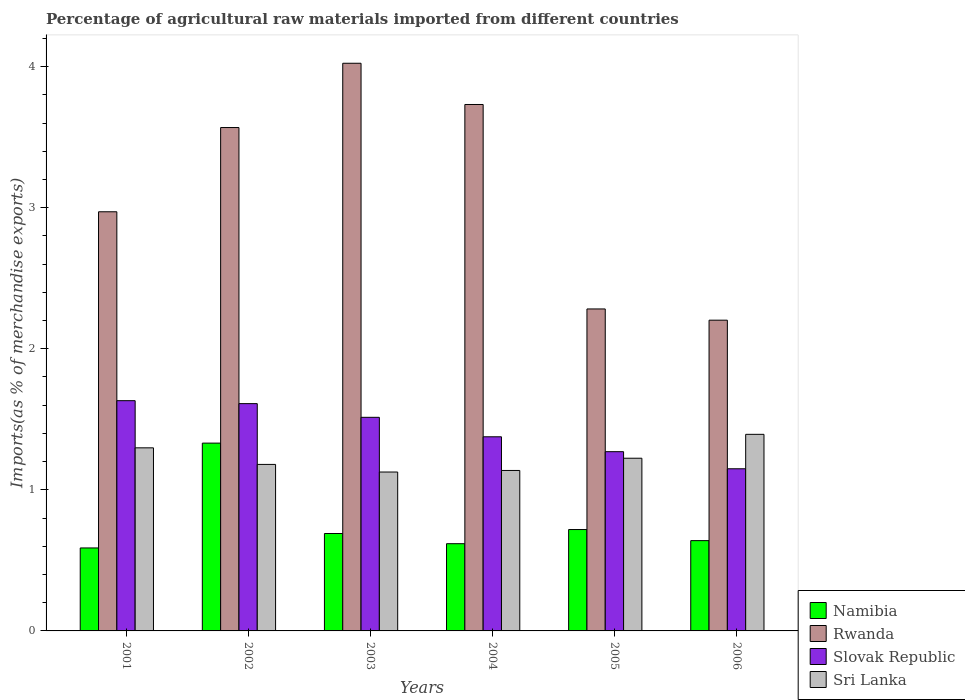How many different coloured bars are there?
Give a very brief answer. 4. How many groups of bars are there?
Keep it short and to the point. 6. Are the number of bars on each tick of the X-axis equal?
Your response must be concise. Yes. How many bars are there on the 2nd tick from the left?
Make the answer very short. 4. How many bars are there on the 2nd tick from the right?
Keep it short and to the point. 4. What is the percentage of imports to different countries in Slovak Republic in 2001?
Ensure brevity in your answer.  1.63. Across all years, what is the maximum percentage of imports to different countries in Rwanda?
Your answer should be very brief. 4.02. Across all years, what is the minimum percentage of imports to different countries in Namibia?
Provide a succinct answer. 0.59. What is the total percentage of imports to different countries in Sri Lanka in the graph?
Offer a terse response. 7.36. What is the difference between the percentage of imports to different countries in Rwanda in 2005 and that in 2006?
Your answer should be compact. 0.08. What is the difference between the percentage of imports to different countries in Slovak Republic in 2003 and the percentage of imports to different countries in Rwanda in 2006?
Your response must be concise. -0.69. What is the average percentage of imports to different countries in Sri Lanka per year?
Offer a terse response. 1.23. In the year 2002, what is the difference between the percentage of imports to different countries in Slovak Republic and percentage of imports to different countries in Sri Lanka?
Provide a succinct answer. 0.43. What is the ratio of the percentage of imports to different countries in Sri Lanka in 2003 to that in 2004?
Give a very brief answer. 0.99. What is the difference between the highest and the second highest percentage of imports to different countries in Slovak Republic?
Offer a terse response. 0.02. What is the difference between the highest and the lowest percentage of imports to different countries in Namibia?
Keep it short and to the point. 0.74. In how many years, is the percentage of imports to different countries in Sri Lanka greater than the average percentage of imports to different countries in Sri Lanka taken over all years?
Your answer should be very brief. 2. What does the 1st bar from the left in 2003 represents?
Keep it short and to the point. Namibia. What does the 4th bar from the right in 2004 represents?
Offer a very short reply. Namibia. Are all the bars in the graph horizontal?
Your answer should be very brief. No. What is the difference between two consecutive major ticks on the Y-axis?
Your answer should be very brief. 1. Does the graph contain any zero values?
Make the answer very short. No. How are the legend labels stacked?
Provide a succinct answer. Vertical. What is the title of the graph?
Ensure brevity in your answer.  Percentage of agricultural raw materials imported from different countries. What is the label or title of the Y-axis?
Your answer should be very brief. Imports(as % of merchandise exports). What is the Imports(as % of merchandise exports) in Namibia in 2001?
Make the answer very short. 0.59. What is the Imports(as % of merchandise exports) in Rwanda in 2001?
Ensure brevity in your answer.  2.97. What is the Imports(as % of merchandise exports) of Slovak Republic in 2001?
Make the answer very short. 1.63. What is the Imports(as % of merchandise exports) of Sri Lanka in 2001?
Keep it short and to the point. 1.3. What is the Imports(as % of merchandise exports) of Namibia in 2002?
Keep it short and to the point. 1.33. What is the Imports(as % of merchandise exports) of Rwanda in 2002?
Provide a short and direct response. 3.57. What is the Imports(as % of merchandise exports) of Slovak Republic in 2002?
Provide a short and direct response. 1.61. What is the Imports(as % of merchandise exports) of Sri Lanka in 2002?
Provide a short and direct response. 1.18. What is the Imports(as % of merchandise exports) in Namibia in 2003?
Your answer should be compact. 0.69. What is the Imports(as % of merchandise exports) in Rwanda in 2003?
Ensure brevity in your answer.  4.02. What is the Imports(as % of merchandise exports) of Slovak Republic in 2003?
Your response must be concise. 1.51. What is the Imports(as % of merchandise exports) in Sri Lanka in 2003?
Your answer should be very brief. 1.13. What is the Imports(as % of merchandise exports) of Namibia in 2004?
Make the answer very short. 0.62. What is the Imports(as % of merchandise exports) in Rwanda in 2004?
Give a very brief answer. 3.73. What is the Imports(as % of merchandise exports) of Slovak Republic in 2004?
Offer a terse response. 1.38. What is the Imports(as % of merchandise exports) of Sri Lanka in 2004?
Provide a short and direct response. 1.14. What is the Imports(as % of merchandise exports) in Namibia in 2005?
Provide a succinct answer. 0.72. What is the Imports(as % of merchandise exports) of Rwanda in 2005?
Your answer should be compact. 2.28. What is the Imports(as % of merchandise exports) of Slovak Republic in 2005?
Offer a terse response. 1.27. What is the Imports(as % of merchandise exports) of Sri Lanka in 2005?
Offer a very short reply. 1.22. What is the Imports(as % of merchandise exports) in Namibia in 2006?
Your answer should be compact. 0.64. What is the Imports(as % of merchandise exports) in Rwanda in 2006?
Your response must be concise. 2.2. What is the Imports(as % of merchandise exports) in Slovak Republic in 2006?
Your answer should be compact. 1.15. What is the Imports(as % of merchandise exports) in Sri Lanka in 2006?
Provide a succinct answer. 1.39. Across all years, what is the maximum Imports(as % of merchandise exports) in Namibia?
Your answer should be very brief. 1.33. Across all years, what is the maximum Imports(as % of merchandise exports) of Rwanda?
Provide a succinct answer. 4.02. Across all years, what is the maximum Imports(as % of merchandise exports) of Slovak Republic?
Provide a succinct answer. 1.63. Across all years, what is the maximum Imports(as % of merchandise exports) of Sri Lanka?
Offer a terse response. 1.39. Across all years, what is the minimum Imports(as % of merchandise exports) in Namibia?
Keep it short and to the point. 0.59. Across all years, what is the minimum Imports(as % of merchandise exports) in Rwanda?
Your answer should be very brief. 2.2. Across all years, what is the minimum Imports(as % of merchandise exports) in Slovak Republic?
Your answer should be compact. 1.15. Across all years, what is the minimum Imports(as % of merchandise exports) in Sri Lanka?
Your answer should be very brief. 1.13. What is the total Imports(as % of merchandise exports) in Namibia in the graph?
Your answer should be compact. 4.59. What is the total Imports(as % of merchandise exports) of Rwanda in the graph?
Keep it short and to the point. 18.78. What is the total Imports(as % of merchandise exports) in Slovak Republic in the graph?
Your answer should be very brief. 8.55. What is the total Imports(as % of merchandise exports) of Sri Lanka in the graph?
Keep it short and to the point. 7.36. What is the difference between the Imports(as % of merchandise exports) of Namibia in 2001 and that in 2002?
Offer a very short reply. -0.74. What is the difference between the Imports(as % of merchandise exports) in Rwanda in 2001 and that in 2002?
Offer a terse response. -0.6. What is the difference between the Imports(as % of merchandise exports) of Slovak Republic in 2001 and that in 2002?
Keep it short and to the point. 0.02. What is the difference between the Imports(as % of merchandise exports) in Sri Lanka in 2001 and that in 2002?
Your response must be concise. 0.12. What is the difference between the Imports(as % of merchandise exports) in Namibia in 2001 and that in 2003?
Make the answer very short. -0.1. What is the difference between the Imports(as % of merchandise exports) in Rwanda in 2001 and that in 2003?
Your answer should be very brief. -1.05. What is the difference between the Imports(as % of merchandise exports) in Slovak Republic in 2001 and that in 2003?
Keep it short and to the point. 0.12. What is the difference between the Imports(as % of merchandise exports) in Sri Lanka in 2001 and that in 2003?
Ensure brevity in your answer.  0.17. What is the difference between the Imports(as % of merchandise exports) of Namibia in 2001 and that in 2004?
Offer a very short reply. -0.03. What is the difference between the Imports(as % of merchandise exports) of Rwanda in 2001 and that in 2004?
Ensure brevity in your answer.  -0.76. What is the difference between the Imports(as % of merchandise exports) in Slovak Republic in 2001 and that in 2004?
Provide a succinct answer. 0.26. What is the difference between the Imports(as % of merchandise exports) of Sri Lanka in 2001 and that in 2004?
Offer a terse response. 0.16. What is the difference between the Imports(as % of merchandise exports) in Namibia in 2001 and that in 2005?
Ensure brevity in your answer.  -0.13. What is the difference between the Imports(as % of merchandise exports) of Rwanda in 2001 and that in 2005?
Offer a terse response. 0.69. What is the difference between the Imports(as % of merchandise exports) in Slovak Republic in 2001 and that in 2005?
Provide a succinct answer. 0.36. What is the difference between the Imports(as % of merchandise exports) in Sri Lanka in 2001 and that in 2005?
Ensure brevity in your answer.  0.07. What is the difference between the Imports(as % of merchandise exports) of Namibia in 2001 and that in 2006?
Ensure brevity in your answer.  -0.05. What is the difference between the Imports(as % of merchandise exports) of Rwanda in 2001 and that in 2006?
Offer a terse response. 0.77. What is the difference between the Imports(as % of merchandise exports) of Slovak Republic in 2001 and that in 2006?
Offer a terse response. 0.48. What is the difference between the Imports(as % of merchandise exports) in Sri Lanka in 2001 and that in 2006?
Give a very brief answer. -0.1. What is the difference between the Imports(as % of merchandise exports) in Namibia in 2002 and that in 2003?
Give a very brief answer. 0.64. What is the difference between the Imports(as % of merchandise exports) of Rwanda in 2002 and that in 2003?
Offer a terse response. -0.46. What is the difference between the Imports(as % of merchandise exports) of Slovak Republic in 2002 and that in 2003?
Ensure brevity in your answer.  0.1. What is the difference between the Imports(as % of merchandise exports) of Sri Lanka in 2002 and that in 2003?
Provide a succinct answer. 0.05. What is the difference between the Imports(as % of merchandise exports) of Namibia in 2002 and that in 2004?
Your answer should be compact. 0.71. What is the difference between the Imports(as % of merchandise exports) in Rwanda in 2002 and that in 2004?
Your answer should be compact. -0.16. What is the difference between the Imports(as % of merchandise exports) in Slovak Republic in 2002 and that in 2004?
Provide a short and direct response. 0.23. What is the difference between the Imports(as % of merchandise exports) of Sri Lanka in 2002 and that in 2004?
Provide a succinct answer. 0.04. What is the difference between the Imports(as % of merchandise exports) in Namibia in 2002 and that in 2005?
Offer a terse response. 0.61. What is the difference between the Imports(as % of merchandise exports) in Rwanda in 2002 and that in 2005?
Your response must be concise. 1.29. What is the difference between the Imports(as % of merchandise exports) in Slovak Republic in 2002 and that in 2005?
Keep it short and to the point. 0.34. What is the difference between the Imports(as % of merchandise exports) in Sri Lanka in 2002 and that in 2005?
Your response must be concise. -0.04. What is the difference between the Imports(as % of merchandise exports) of Namibia in 2002 and that in 2006?
Give a very brief answer. 0.69. What is the difference between the Imports(as % of merchandise exports) in Rwanda in 2002 and that in 2006?
Give a very brief answer. 1.37. What is the difference between the Imports(as % of merchandise exports) in Slovak Republic in 2002 and that in 2006?
Ensure brevity in your answer.  0.46. What is the difference between the Imports(as % of merchandise exports) of Sri Lanka in 2002 and that in 2006?
Keep it short and to the point. -0.21. What is the difference between the Imports(as % of merchandise exports) of Namibia in 2003 and that in 2004?
Make the answer very short. 0.07. What is the difference between the Imports(as % of merchandise exports) in Rwanda in 2003 and that in 2004?
Give a very brief answer. 0.29. What is the difference between the Imports(as % of merchandise exports) of Slovak Republic in 2003 and that in 2004?
Ensure brevity in your answer.  0.14. What is the difference between the Imports(as % of merchandise exports) in Sri Lanka in 2003 and that in 2004?
Your answer should be compact. -0.01. What is the difference between the Imports(as % of merchandise exports) in Namibia in 2003 and that in 2005?
Provide a succinct answer. -0.03. What is the difference between the Imports(as % of merchandise exports) of Rwanda in 2003 and that in 2005?
Provide a succinct answer. 1.74. What is the difference between the Imports(as % of merchandise exports) of Slovak Republic in 2003 and that in 2005?
Provide a succinct answer. 0.24. What is the difference between the Imports(as % of merchandise exports) of Sri Lanka in 2003 and that in 2005?
Provide a short and direct response. -0.1. What is the difference between the Imports(as % of merchandise exports) of Namibia in 2003 and that in 2006?
Make the answer very short. 0.05. What is the difference between the Imports(as % of merchandise exports) in Rwanda in 2003 and that in 2006?
Ensure brevity in your answer.  1.82. What is the difference between the Imports(as % of merchandise exports) in Slovak Republic in 2003 and that in 2006?
Your answer should be compact. 0.36. What is the difference between the Imports(as % of merchandise exports) in Sri Lanka in 2003 and that in 2006?
Ensure brevity in your answer.  -0.27. What is the difference between the Imports(as % of merchandise exports) in Namibia in 2004 and that in 2005?
Your answer should be very brief. -0.1. What is the difference between the Imports(as % of merchandise exports) in Rwanda in 2004 and that in 2005?
Offer a very short reply. 1.45. What is the difference between the Imports(as % of merchandise exports) of Slovak Republic in 2004 and that in 2005?
Keep it short and to the point. 0.11. What is the difference between the Imports(as % of merchandise exports) of Sri Lanka in 2004 and that in 2005?
Provide a succinct answer. -0.09. What is the difference between the Imports(as % of merchandise exports) in Namibia in 2004 and that in 2006?
Your response must be concise. -0.02. What is the difference between the Imports(as % of merchandise exports) of Rwanda in 2004 and that in 2006?
Provide a short and direct response. 1.53. What is the difference between the Imports(as % of merchandise exports) of Slovak Republic in 2004 and that in 2006?
Offer a very short reply. 0.23. What is the difference between the Imports(as % of merchandise exports) of Sri Lanka in 2004 and that in 2006?
Offer a terse response. -0.26. What is the difference between the Imports(as % of merchandise exports) in Namibia in 2005 and that in 2006?
Offer a very short reply. 0.08. What is the difference between the Imports(as % of merchandise exports) of Rwanda in 2005 and that in 2006?
Offer a very short reply. 0.08. What is the difference between the Imports(as % of merchandise exports) of Slovak Republic in 2005 and that in 2006?
Keep it short and to the point. 0.12. What is the difference between the Imports(as % of merchandise exports) in Sri Lanka in 2005 and that in 2006?
Offer a terse response. -0.17. What is the difference between the Imports(as % of merchandise exports) in Namibia in 2001 and the Imports(as % of merchandise exports) in Rwanda in 2002?
Ensure brevity in your answer.  -2.98. What is the difference between the Imports(as % of merchandise exports) in Namibia in 2001 and the Imports(as % of merchandise exports) in Slovak Republic in 2002?
Your answer should be compact. -1.02. What is the difference between the Imports(as % of merchandise exports) of Namibia in 2001 and the Imports(as % of merchandise exports) of Sri Lanka in 2002?
Make the answer very short. -0.59. What is the difference between the Imports(as % of merchandise exports) in Rwanda in 2001 and the Imports(as % of merchandise exports) in Slovak Republic in 2002?
Your answer should be compact. 1.36. What is the difference between the Imports(as % of merchandise exports) of Rwanda in 2001 and the Imports(as % of merchandise exports) of Sri Lanka in 2002?
Your answer should be compact. 1.79. What is the difference between the Imports(as % of merchandise exports) of Slovak Republic in 2001 and the Imports(as % of merchandise exports) of Sri Lanka in 2002?
Provide a succinct answer. 0.45. What is the difference between the Imports(as % of merchandise exports) in Namibia in 2001 and the Imports(as % of merchandise exports) in Rwanda in 2003?
Your answer should be compact. -3.44. What is the difference between the Imports(as % of merchandise exports) in Namibia in 2001 and the Imports(as % of merchandise exports) in Slovak Republic in 2003?
Your answer should be very brief. -0.93. What is the difference between the Imports(as % of merchandise exports) in Namibia in 2001 and the Imports(as % of merchandise exports) in Sri Lanka in 2003?
Offer a very short reply. -0.54. What is the difference between the Imports(as % of merchandise exports) of Rwanda in 2001 and the Imports(as % of merchandise exports) of Slovak Republic in 2003?
Offer a very short reply. 1.46. What is the difference between the Imports(as % of merchandise exports) in Rwanda in 2001 and the Imports(as % of merchandise exports) in Sri Lanka in 2003?
Offer a terse response. 1.84. What is the difference between the Imports(as % of merchandise exports) in Slovak Republic in 2001 and the Imports(as % of merchandise exports) in Sri Lanka in 2003?
Provide a short and direct response. 0.51. What is the difference between the Imports(as % of merchandise exports) in Namibia in 2001 and the Imports(as % of merchandise exports) in Rwanda in 2004?
Your answer should be very brief. -3.14. What is the difference between the Imports(as % of merchandise exports) of Namibia in 2001 and the Imports(as % of merchandise exports) of Slovak Republic in 2004?
Ensure brevity in your answer.  -0.79. What is the difference between the Imports(as % of merchandise exports) in Namibia in 2001 and the Imports(as % of merchandise exports) in Sri Lanka in 2004?
Your response must be concise. -0.55. What is the difference between the Imports(as % of merchandise exports) of Rwanda in 2001 and the Imports(as % of merchandise exports) of Slovak Republic in 2004?
Provide a short and direct response. 1.59. What is the difference between the Imports(as % of merchandise exports) of Rwanda in 2001 and the Imports(as % of merchandise exports) of Sri Lanka in 2004?
Provide a short and direct response. 1.83. What is the difference between the Imports(as % of merchandise exports) of Slovak Republic in 2001 and the Imports(as % of merchandise exports) of Sri Lanka in 2004?
Ensure brevity in your answer.  0.49. What is the difference between the Imports(as % of merchandise exports) of Namibia in 2001 and the Imports(as % of merchandise exports) of Rwanda in 2005?
Provide a succinct answer. -1.69. What is the difference between the Imports(as % of merchandise exports) of Namibia in 2001 and the Imports(as % of merchandise exports) of Slovak Republic in 2005?
Your answer should be very brief. -0.68. What is the difference between the Imports(as % of merchandise exports) in Namibia in 2001 and the Imports(as % of merchandise exports) in Sri Lanka in 2005?
Offer a very short reply. -0.64. What is the difference between the Imports(as % of merchandise exports) in Rwanda in 2001 and the Imports(as % of merchandise exports) in Slovak Republic in 2005?
Your answer should be compact. 1.7. What is the difference between the Imports(as % of merchandise exports) in Rwanda in 2001 and the Imports(as % of merchandise exports) in Sri Lanka in 2005?
Make the answer very short. 1.75. What is the difference between the Imports(as % of merchandise exports) in Slovak Republic in 2001 and the Imports(as % of merchandise exports) in Sri Lanka in 2005?
Make the answer very short. 0.41. What is the difference between the Imports(as % of merchandise exports) in Namibia in 2001 and the Imports(as % of merchandise exports) in Rwanda in 2006?
Provide a succinct answer. -1.61. What is the difference between the Imports(as % of merchandise exports) in Namibia in 2001 and the Imports(as % of merchandise exports) in Slovak Republic in 2006?
Provide a succinct answer. -0.56. What is the difference between the Imports(as % of merchandise exports) of Namibia in 2001 and the Imports(as % of merchandise exports) of Sri Lanka in 2006?
Your answer should be very brief. -0.81. What is the difference between the Imports(as % of merchandise exports) in Rwanda in 2001 and the Imports(as % of merchandise exports) in Slovak Republic in 2006?
Your answer should be very brief. 1.82. What is the difference between the Imports(as % of merchandise exports) in Rwanda in 2001 and the Imports(as % of merchandise exports) in Sri Lanka in 2006?
Give a very brief answer. 1.58. What is the difference between the Imports(as % of merchandise exports) of Slovak Republic in 2001 and the Imports(as % of merchandise exports) of Sri Lanka in 2006?
Your response must be concise. 0.24. What is the difference between the Imports(as % of merchandise exports) of Namibia in 2002 and the Imports(as % of merchandise exports) of Rwanda in 2003?
Your response must be concise. -2.69. What is the difference between the Imports(as % of merchandise exports) in Namibia in 2002 and the Imports(as % of merchandise exports) in Slovak Republic in 2003?
Keep it short and to the point. -0.18. What is the difference between the Imports(as % of merchandise exports) of Namibia in 2002 and the Imports(as % of merchandise exports) of Sri Lanka in 2003?
Your response must be concise. 0.2. What is the difference between the Imports(as % of merchandise exports) in Rwanda in 2002 and the Imports(as % of merchandise exports) in Slovak Republic in 2003?
Provide a short and direct response. 2.05. What is the difference between the Imports(as % of merchandise exports) of Rwanda in 2002 and the Imports(as % of merchandise exports) of Sri Lanka in 2003?
Ensure brevity in your answer.  2.44. What is the difference between the Imports(as % of merchandise exports) of Slovak Republic in 2002 and the Imports(as % of merchandise exports) of Sri Lanka in 2003?
Offer a terse response. 0.48. What is the difference between the Imports(as % of merchandise exports) of Namibia in 2002 and the Imports(as % of merchandise exports) of Rwanda in 2004?
Ensure brevity in your answer.  -2.4. What is the difference between the Imports(as % of merchandise exports) of Namibia in 2002 and the Imports(as % of merchandise exports) of Slovak Republic in 2004?
Provide a short and direct response. -0.04. What is the difference between the Imports(as % of merchandise exports) in Namibia in 2002 and the Imports(as % of merchandise exports) in Sri Lanka in 2004?
Provide a succinct answer. 0.19. What is the difference between the Imports(as % of merchandise exports) of Rwanda in 2002 and the Imports(as % of merchandise exports) of Slovak Republic in 2004?
Your answer should be compact. 2.19. What is the difference between the Imports(as % of merchandise exports) in Rwanda in 2002 and the Imports(as % of merchandise exports) in Sri Lanka in 2004?
Keep it short and to the point. 2.43. What is the difference between the Imports(as % of merchandise exports) of Slovak Republic in 2002 and the Imports(as % of merchandise exports) of Sri Lanka in 2004?
Ensure brevity in your answer.  0.47. What is the difference between the Imports(as % of merchandise exports) of Namibia in 2002 and the Imports(as % of merchandise exports) of Rwanda in 2005?
Make the answer very short. -0.95. What is the difference between the Imports(as % of merchandise exports) of Namibia in 2002 and the Imports(as % of merchandise exports) of Slovak Republic in 2005?
Provide a short and direct response. 0.06. What is the difference between the Imports(as % of merchandise exports) of Namibia in 2002 and the Imports(as % of merchandise exports) of Sri Lanka in 2005?
Provide a succinct answer. 0.11. What is the difference between the Imports(as % of merchandise exports) of Rwanda in 2002 and the Imports(as % of merchandise exports) of Slovak Republic in 2005?
Your answer should be compact. 2.3. What is the difference between the Imports(as % of merchandise exports) in Rwanda in 2002 and the Imports(as % of merchandise exports) in Sri Lanka in 2005?
Ensure brevity in your answer.  2.34. What is the difference between the Imports(as % of merchandise exports) of Slovak Republic in 2002 and the Imports(as % of merchandise exports) of Sri Lanka in 2005?
Give a very brief answer. 0.39. What is the difference between the Imports(as % of merchandise exports) of Namibia in 2002 and the Imports(as % of merchandise exports) of Rwanda in 2006?
Your answer should be very brief. -0.87. What is the difference between the Imports(as % of merchandise exports) in Namibia in 2002 and the Imports(as % of merchandise exports) in Slovak Republic in 2006?
Keep it short and to the point. 0.18. What is the difference between the Imports(as % of merchandise exports) in Namibia in 2002 and the Imports(as % of merchandise exports) in Sri Lanka in 2006?
Provide a short and direct response. -0.06. What is the difference between the Imports(as % of merchandise exports) of Rwanda in 2002 and the Imports(as % of merchandise exports) of Slovak Republic in 2006?
Provide a succinct answer. 2.42. What is the difference between the Imports(as % of merchandise exports) of Rwanda in 2002 and the Imports(as % of merchandise exports) of Sri Lanka in 2006?
Ensure brevity in your answer.  2.17. What is the difference between the Imports(as % of merchandise exports) in Slovak Republic in 2002 and the Imports(as % of merchandise exports) in Sri Lanka in 2006?
Your response must be concise. 0.22. What is the difference between the Imports(as % of merchandise exports) in Namibia in 2003 and the Imports(as % of merchandise exports) in Rwanda in 2004?
Provide a short and direct response. -3.04. What is the difference between the Imports(as % of merchandise exports) in Namibia in 2003 and the Imports(as % of merchandise exports) in Slovak Republic in 2004?
Your answer should be compact. -0.69. What is the difference between the Imports(as % of merchandise exports) in Namibia in 2003 and the Imports(as % of merchandise exports) in Sri Lanka in 2004?
Keep it short and to the point. -0.45. What is the difference between the Imports(as % of merchandise exports) in Rwanda in 2003 and the Imports(as % of merchandise exports) in Slovak Republic in 2004?
Your response must be concise. 2.65. What is the difference between the Imports(as % of merchandise exports) in Rwanda in 2003 and the Imports(as % of merchandise exports) in Sri Lanka in 2004?
Your answer should be compact. 2.89. What is the difference between the Imports(as % of merchandise exports) of Slovak Republic in 2003 and the Imports(as % of merchandise exports) of Sri Lanka in 2004?
Give a very brief answer. 0.38. What is the difference between the Imports(as % of merchandise exports) in Namibia in 2003 and the Imports(as % of merchandise exports) in Rwanda in 2005?
Provide a succinct answer. -1.59. What is the difference between the Imports(as % of merchandise exports) of Namibia in 2003 and the Imports(as % of merchandise exports) of Slovak Republic in 2005?
Offer a terse response. -0.58. What is the difference between the Imports(as % of merchandise exports) in Namibia in 2003 and the Imports(as % of merchandise exports) in Sri Lanka in 2005?
Give a very brief answer. -0.53. What is the difference between the Imports(as % of merchandise exports) of Rwanda in 2003 and the Imports(as % of merchandise exports) of Slovak Republic in 2005?
Give a very brief answer. 2.75. What is the difference between the Imports(as % of merchandise exports) of Rwanda in 2003 and the Imports(as % of merchandise exports) of Sri Lanka in 2005?
Your response must be concise. 2.8. What is the difference between the Imports(as % of merchandise exports) of Slovak Republic in 2003 and the Imports(as % of merchandise exports) of Sri Lanka in 2005?
Your answer should be very brief. 0.29. What is the difference between the Imports(as % of merchandise exports) of Namibia in 2003 and the Imports(as % of merchandise exports) of Rwanda in 2006?
Keep it short and to the point. -1.51. What is the difference between the Imports(as % of merchandise exports) of Namibia in 2003 and the Imports(as % of merchandise exports) of Slovak Republic in 2006?
Keep it short and to the point. -0.46. What is the difference between the Imports(as % of merchandise exports) in Namibia in 2003 and the Imports(as % of merchandise exports) in Sri Lanka in 2006?
Your answer should be compact. -0.7. What is the difference between the Imports(as % of merchandise exports) in Rwanda in 2003 and the Imports(as % of merchandise exports) in Slovak Republic in 2006?
Offer a terse response. 2.87. What is the difference between the Imports(as % of merchandise exports) in Rwanda in 2003 and the Imports(as % of merchandise exports) in Sri Lanka in 2006?
Provide a succinct answer. 2.63. What is the difference between the Imports(as % of merchandise exports) of Slovak Republic in 2003 and the Imports(as % of merchandise exports) of Sri Lanka in 2006?
Provide a short and direct response. 0.12. What is the difference between the Imports(as % of merchandise exports) in Namibia in 2004 and the Imports(as % of merchandise exports) in Rwanda in 2005?
Offer a terse response. -1.66. What is the difference between the Imports(as % of merchandise exports) of Namibia in 2004 and the Imports(as % of merchandise exports) of Slovak Republic in 2005?
Your answer should be compact. -0.65. What is the difference between the Imports(as % of merchandise exports) in Namibia in 2004 and the Imports(as % of merchandise exports) in Sri Lanka in 2005?
Offer a terse response. -0.61. What is the difference between the Imports(as % of merchandise exports) of Rwanda in 2004 and the Imports(as % of merchandise exports) of Slovak Republic in 2005?
Give a very brief answer. 2.46. What is the difference between the Imports(as % of merchandise exports) of Rwanda in 2004 and the Imports(as % of merchandise exports) of Sri Lanka in 2005?
Provide a short and direct response. 2.51. What is the difference between the Imports(as % of merchandise exports) of Slovak Republic in 2004 and the Imports(as % of merchandise exports) of Sri Lanka in 2005?
Ensure brevity in your answer.  0.15. What is the difference between the Imports(as % of merchandise exports) of Namibia in 2004 and the Imports(as % of merchandise exports) of Rwanda in 2006?
Offer a very short reply. -1.58. What is the difference between the Imports(as % of merchandise exports) in Namibia in 2004 and the Imports(as % of merchandise exports) in Slovak Republic in 2006?
Your answer should be very brief. -0.53. What is the difference between the Imports(as % of merchandise exports) in Namibia in 2004 and the Imports(as % of merchandise exports) in Sri Lanka in 2006?
Offer a terse response. -0.78. What is the difference between the Imports(as % of merchandise exports) in Rwanda in 2004 and the Imports(as % of merchandise exports) in Slovak Republic in 2006?
Keep it short and to the point. 2.58. What is the difference between the Imports(as % of merchandise exports) of Rwanda in 2004 and the Imports(as % of merchandise exports) of Sri Lanka in 2006?
Your response must be concise. 2.34. What is the difference between the Imports(as % of merchandise exports) of Slovak Republic in 2004 and the Imports(as % of merchandise exports) of Sri Lanka in 2006?
Your answer should be compact. -0.02. What is the difference between the Imports(as % of merchandise exports) in Namibia in 2005 and the Imports(as % of merchandise exports) in Rwanda in 2006?
Offer a very short reply. -1.48. What is the difference between the Imports(as % of merchandise exports) of Namibia in 2005 and the Imports(as % of merchandise exports) of Slovak Republic in 2006?
Make the answer very short. -0.43. What is the difference between the Imports(as % of merchandise exports) in Namibia in 2005 and the Imports(as % of merchandise exports) in Sri Lanka in 2006?
Ensure brevity in your answer.  -0.67. What is the difference between the Imports(as % of merchandise exports) of Rwanda in 2005 and the Imports(as % of merchandise exports) of Slovak Republic in 2006?
Your answer should be very brief. 1.13. What is the difference between the Imports(as % of merchandise exports) in Rwanda in 2005 and the Imports(as % of merchandise exports) in Sri Lanka in 2006?
Offer a very short reply. 0.89. What is the difference between the Imports(as % of merchandise exports) in Slovak Republic in 2005 and the Imports(as % of merchandise exports) in Sri Lanka in 2006?
Give a very brief answer. -0.12. What is the average Imports(as % of merchandise exports) in Namibia per year?
Make the answer very short. 0.76. What is the average Imports(as % of merchandise exports) of Rwanda per year?
Make the answer very short. 3.13. What is the average Imports(as % of merchandise exports) of Slovak Republic per year?
Keep it short and to the point. 1.43. What is the average Imports(as % of merchandise exports) in Sri Lanka per year?
Provide a short and direct response. 1.23. In the year 2001, what is the difference between the Imports(as % of merchandise exports) of Namibia and Imports(as % of merchandise exports) of Rwanda?
Make the answer very short. -2.38. In the year 2001, what is the difference between the Imports(as % of merchandise exports) in Namibia and Imports(as % of merchandise exports) in Slovak Republic?
Offer a very short reply. -1.04. In the year 2001, what is the difference between the Imports(as % of merchandise exports) of Namibia and Imports(as % of merchandise exports) of Sri Lanka?
Make the answer very short. -0.71. In the year 2001, what is the difference between the Imports(as % of merchandise exports) in Rwanda and Imports(as % of merchandise exports) in Slovak Republic?
Provide a short and direct response. 1.34. In the year 2001, what is the difference between the Imports(as % of merchandise exports) in Rwanda and Imports(as % of merchandise exports) in Sri Lanka?
Offer a terse response. 1.67. In the year 2001, what is the difference between the Imports(as % of merchandise exports) of Slovak Republic and Imports(as % of merchandise exports) of Sri Lanka?
Provide a succinct answer. 0.33. In the year 2002, what is the difference between the Imports(as % of merchandise exports) of Namibia and Imports(as % of merchandise exports) of Rwanda?
Offer a terse response. -2.24. In the year 2002, what is the difference between the Imports(as % of merchandise exports) in Namibia and Imports(as % of merchandise exports) in Slovak Republic?
Your response must be concise. -0.28. In the year 2002, what is the difference between the Imports(as % of merchandise exports) of Namibia and Imports(as % of merchandise exports) of Sri Lanka?
Provide a succinct answer. 0.15. In the year 2002, what is the difference between the Imports(as % of merchandise exports) of Rwanda and Imports(as % of merchandise exports) of Slovak Republic?
Your response must be concise. 1.96. In the year 2002, what is the difference between the Imports(as % of merchandise exports) of Rwanda and Imports(as % of merchandise exports) of Sri Lanka?
Keep it short and to the point. 2.39. In the year 2002, what is the difference between the Imports(as % of merchandise exports) in Slovak Republic and Imports(as % of merchandise exports) in Sri Lanka?
Your answer should be compact. 0.43. In the year 2003, what is the difference between the Imports(as % of merchandise exports) in Namibia and Imports(as % of merchandise exports) in Slovak Republic?
Offer a very short reply. -0.82. In the year 2003, what is the difference between the Imports(as % of merchandise exports) in Namibia and Imports(as % of merchandise exports) in Sri Lanka?
Provide a short and direct response. -0.44. In the year 2003, what is the difference between the Imports(as % of merchandise exports) of Rwanda and Imports(as % of merchandise exports) of Slovak Republic?
Offer a terse response. 2.51. In the year 2003, what is the difference between the Imports(as % of merchandise exports) of Rwanda and Imports(as % of merchandise exports) of Sri Lanka?
Your answer should be compact. 2.9. In the year 2003, what is the difference between the Imports(as % of merchandise exports) of Slovak Republic and Imports(as % of merchandise exports) of Sri Lanka?
Your answer should be very brief. 0.39. In the year 2004, what is the difference between the Imports(as % of merchandise exports) of Namibia and Imports(as % of merchandise exports) of Rwanda?
Provide a short and direct response. -3.11. In the year 2004, what is the difference between the Imports(as % of merchandise exports) in Namibia and Imports(as % of merchandise exports) in Slovak Republic?
Give a very brief answer. -0.76. In the year 2004, what is the difference between the Imports(as % of merchandise exports) of Namibia and Imports(as % of merchandise exports) of Sri Lanka?
Your response must be concise. -0.52. In the year 2004, what is the difference between the Imports(as % of merchandise exports) in Rwanda and Imports(as % of merchandise exports) in Slovak Republic?
Keep it short and to the point. 2.36. In the year 2004, what is the difference between the Imports(as % of merchandise exports) in Rwanda and Imports(as % of merchandise exports) in Sri Lanka?
Ensure brevity in your answer.  2.59. In the year 2004, what is the difference between the Imports(as % of merchandise exports) of Slovak Republic and Imports(as % of merchandise exports) of Sri Lanka?
Your response must be concise. 0.24. In the year 2005, what is the difference between the Imports(as % of merchandise exports) in Namibia and Imports(as % of merchandise exports) in Rwanda?
Keep it short and to the point. -1.56. In the year 2005, what is the difference between the Imports(as % of merchandise exports) in Namibia and Imports(as % of merchandise exports) in Slovak Republic?
Your response must be concise. -0.55. In the year 2005, what is the difference between the Imports(as % of merchandise exports) in Namibia and Imports(as % of merchandise exports) in Sri Lanka?
Offer a terse response. -0.51. In the year 2005, what is the difference between the Imports(as % of merchandise exports) in Rwanda and Imports(as % of merchandise exports) in Slovak Republic?
Your response must be concise. 1.01. In the year 2005, what is the difference between the Imports(as % of merchandise exports) in Rwanda and Imports(as % of merchandise exports) in Sri Lanka?
Provide a short and direct response. 1.06. In the year 2005, what is the difference between the Imports(as % of merchandise exports) in Slovak Republic and Imports(as % of merchandise exports) in Sri Lanka?
Keep it short and to the point. 0.05. In the year 2006, what is the difference between the Imports(as % of merchandise exports) in Namibia and Imports(as % of merchandise exports) in Rwanda?
Ensure brevity in your answer.  -1.56. In the year 2006, what is the difference between the Imports(as % of merchandise exports) in Namibia and Imports(as % of merchandise exports) in Slovak Republic?
Keep it short and to the point. -0.51. In the year 2006, what is the difference between the Imports(as % of merchandise exports) of Namibia and Imports(as % of merchandise exports) of Sri Lanka?
Your answer should be compact. -0.75. In the year 2006, what is the difference between the Imports(as % of merchandise exports) in Rwanda and Imports(as % of merchandise exports) in Slovak Republic?
Give a very brief answer. 1.05. In the year 2006, what is the difference between the Imports(as % of merchandise exports) of Rwanda and Imports(as % of merchandise exports) of Sri Lanka?
Your response must be concise. 0.81. In the year 2006, what is the difference between the Imports(as % of merchandise exports) in Slovak Republic and Imports(as % of merchandise exports) in Sri Lanka?
Ensure brevity in your answer.  -0.24. What is the ratio of the Imports(as % of merchandise exports) of Namibia in 2001 to that in 2002?
Your answer should be very brief. 0.44. What is the ratio of the Imports(as % of merchandise exports) of Rwanda in 2001 to that in 2002?
Make the answer very short. 0.83. What is the ratio of the Imports(as % of merchandise exports) in Sri Lanka in 2001 to that in 2002?
Keep it short and to the point. 1.1. What is the ratio of the Imports(as % of merchandise exports) in Namibia in 2001 to that in 2003?
Your answer should be compact. 0.85. What is the ratio of the Imports(as % of merchandise exports) in Rwanda in 2001 to that in 2003?
Provide a succinct answer. 0.74. What is the ratio of the Imports(as % of merchandise exports) of Slovak Republic in 2001 to that in 2003?
Provide a succinct answer. 1.08. What is the ratio of the Imports(as % of merchandise exports) in Sri Lanka in 2001 to that in 2003?
Ensure brevity in your answer.  1.15. What is the ratio of the Imports(as % of merchandise exports) in Namibia in 2001 to that in 2004?
Keep it short and to the point. 0.95. What is the ratio of the Imports(as % of merchandise exports) of Rwanda in 2001 to that in 2004?
Your answer should be compact. 0.8. What is the ratio of the Imports(as % of merchandise exports) in Slovak Republic in 2001 to that in 2004?
Your response must be concise. 1.19. What is the ratio of the Imports(as % of merchandise exports) in Sri Lanka in 2001 to that in 2004?
Offer a terse response. 1.14. What is the ratio of the Imports(as % of merchandise exports) of Namibia in 2001 to that in 2005?
Give a very brief answer. 0.82. What is the ratio of the Imports(as % of merchandise exports) in Rwanda in 2001 to that in 2005?
Provide a succinct answer. 1.3. What is the ratio of the Imports(as % of merchandise exports) in Slovak Republic in 2001 to that in 2005?
Offer a very short reply. 1.28. What is the ratio of the Imports(as % of merchandise exports) of Sri Lanka in 2001 to that in 2005?
Keep it short and to the point. 1.06. What is the ratio of the Imports(as % of merchandise exports) of Namibia in 2001 to that in 2006?
Provide a succinct answer. 0.92. What is the ratio of the Imports(as % of merchandise exports) of Rwanda in 2001 to that in 2006?
Keep it short and to the point. 1.35. What is the ratio of the Imports(as % of merchandise exports) in Slovak Republic in 2001 to that in 2006?
Give a very brief answer. 1.42. What is the ratio of the Imports(as % of merchandise exports) in Sri Lanka in 2001 to that in 2006?
Provide a succinct answer. 0.93. What is the ratio of the Imports(as % of merchandise exports) of Namibia in 2002 to that in 2003?
Offer a terse response. 1.93. What is the ratio of the Imports(as % of merchandise exports) in Rwanda in 2002 to that in 2003?
Provide a succinct answer. 0.89. What is the ratio of the Imports(as % of merchandise exports) of Slovak Republic in 2002 to that in 2003?
Give a very brief answer. 1.06. What is the ratio of the Imports(as % of merchandise exports) of Sri Lanka in 2002 to that in 2003?
Your answer should be compact. 1.05. What is the ratio of the Imports(as % of merchandise exports) of Namibia in 2002 to that in 2004?
Provide a short and direct response. 2.15. What is the ratio of the Imports(as % of merchandise exports) of Rwanda in 2002 to that in 2004?
Give a very brief answer. 0.96. What is the ratio of the Imports(as % of merchandise exports) in Slovak Republic in 2002 to that in 2004?
Ensure brevity in your answer.  1.17. What is the ratio of the Imports(as % of merchandise exports) in Sri Lanka in 2002 to that in 2004?
Your response must be concise. 1.04. What is the ratio of the Imports(as % of merchandise exports) of Namibia in 2002 to that in 2005?
Your response must be concise. 1.85. What is the ratio of the Imports(as % of merchandise exports) of Rwanda in 2002 to that in 2005?
Keep it short and to the point. 1.56. What is the ratio of the Imports(as % of merchandise exports) in Slovak Republic in 2002 to that in 2005?
Offer a terse response. 1.27. What is the ratio of the Imports(as % of merchandise exports) in Sri Lanka in 2002 to that in 2005?
Your answer should be very brief. 0.96. What is the ratio of the Imports(as % of merchandise exports) of Namibia in 2002 to that in 2006?
Keep it short and to the point. 2.08. What is the ratio of the Imports(as % of merchandise exports) of Rwanda in 2002 to that in 2006?
Offer a very short reply. 1.62. What is the ratio of the Imports(as % of merchandise exports) in Slovak Republic in 2002 to that in 2006?
Your answer should be very brief. 1.4. What is the ratio of the Imports(as % of merchandise exports) of Sri Lanka in 2002 to that in 2006?
Offer a terse response. 0.85. What is the ratio of the Imports(as % of merchandise exports) of Namibia in 2003 to that in 2004?
Your answer should be very brief. 1.12. What is the ratio of the Imports(as % of merchandise exports) in Rwanda in 2003 to that in 2004?
Give a very brief answer. 1.08. What is the ratio of the Imports(as % of merchandise exports) in Slovak Republic in 2003 to that in 2004?
Provide a short and direct response. 1.1. What is the ratio of the Imports(as % of merchandise exports) of Sri Lanka in 2003 to that in 2004?
Offer a very short reply. 0.99. What is the ratio of the Imports(as % of merchandise exports) in Namibia in 2003 to that in 2005?
Provide a succinct answer. 0.96. What is the ratio of the Imports(as % of merchandise exports) in Rwanda in 2003 to that in 2005?
Your answer should be very brief. 1.76. What is the ratio of the Imports(as % of merchandise exports) of Slovak Republic in 2003 to that in 2005?
Provide a succinct answer. 1.19. What is the ratio of the Imports(as % of merchandise exports) in Sri Lanka in 2003 to that in 2005?
Your answer should be compact. 0.92. What is the ratio of the Imports(as % of merchandise exports) in Namibia in 2003 to that in 2006?
Your answer should be compact. 1.08. What is the ratio of the Imports(as % of merchandise exports) in Rwanda in 2003 to that in 2006?
Give a very brief answer. 1.83. What is the ratio of the Imports(as % of merchandise exports) of Slovak Republic in 2003 to that in 2006?
Make the answer very short. 1.32. What is the ratio of the Imports(as % of merchandise exports) of Sri Lanka in 2003 to that in 2006?
Your answer should be very brief. 0.81. What is the ratio of the Imports(as % of merchandise exports) in Namibia in 2004 to that in 2005?
Provide a short and direct response. 0.86. What is the ratio of the Imports(as % of merchandise exports) in Rwanda in 2004 to that in 2005?
Give a very brief answer. 1.64. What is the ratio of the Imports(as % of merchandise exports) in Slovak Republic in 2004 to that in 2005?
Keep it short and to the point. 1.08. What is the ratio of the Imports(as % of merchandise exports) in Sri Lanka in 2004 to that in 2005?
Provide a short and direct response. 0.93. What is the ratio of the Imports(as % of merchandise exports) in Namibia in 2004 to that in 2006?
Your answer should be very brief. 0.97. What is the ratio of the Imports(as % of merchandise exports) in Rwanda in 2004 to that in 2006?
Your answer should be compact. 1.69. What is the ratio of the Imports(as % of merchandise exports) of Slovak Republic in 2004 to that in 2006?
Offer a very short reply. 1.2. What is the ratio of the Imports(as % of merchandise exports) in Sri Lanka in 2004 to that in 2006?
Make the answer very short. 0.82. What is the ratio of the Imports(as % of merchandise exports) of Namibia in 2005 to that in 2006?
Provide a short and direct response. 1.12. What is the ratio of the Imports(as % of merchandise exports) of Rwanda in 2005 to that in 2006?
Keep it short and to the point. 1.04. What is the ratio of the Imports(as % of merchandise exports) in Slovak Republic in 2005 to that in 2006?
Provide a succinct answer. 1.11. What is the ratio of the Imports(as % of merchandise exports) in Sri Lanka in 2005 to that in 2006?
Your answer should be compact. 0.88. What is the difference between the highest and the second highest Imports(as % of merchandise exports) in Namibia?
Provide a succinct answer. 0.61. What is the difference between the highest and the second highest Imports(as % of merchandise exports) of Rwanda?
Your answer should be compact. 0.29. What is the difference between the highest and the second highest Imports(as % of merchandise exports) of Slovak Republic?
Your answer should be very brief. 0.02. What is the difference between the highest and the second highest Imports(as % of merchandise exports) of Sri Lanka?
Your answer should be compact. 0.1. What is the difference between the highest and the lowest Imports(as % of merchandise exports) in Namibia?
Offer a very short reply. 0.74. What is the difference between the highest and the lowest Imports(as % of merchandise exports) of Rwanda?
Your response must be concise. 1.82. What is the difference between the highest and the lowest Imports(as % of merchandise exports) of Slovak Republic?
Ensure brevity in your answer.  0.48. What is the difference between the highest and the lowest Imports(as % of merchandise exports) of Sri Lanka?
Provide a short and direct response. 0.27. 